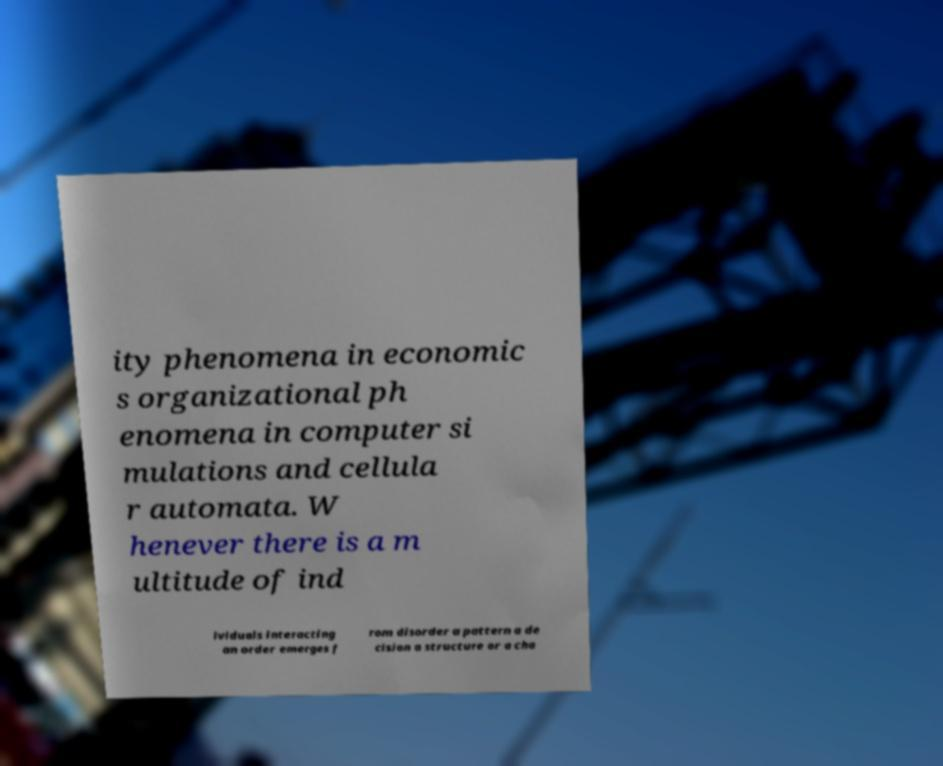There's text embedded in this image that I need extracted. Can you transcribe it verbatim? ity phenomena in economic s organizational ph enomena in computer si mulations and cellula r automata. W henever there is a m ultitude of ind ividuals interacting an order emerges f rom disorder a pattern a de cision a structure or a cha 